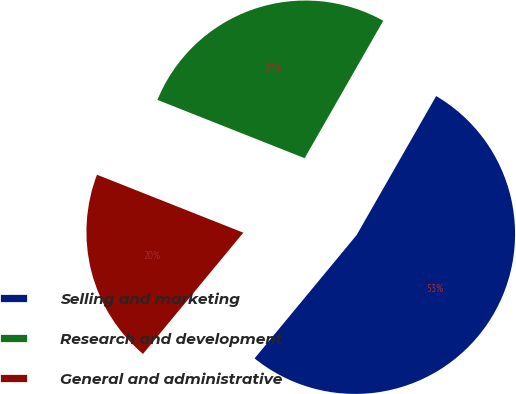Convert chart. <chart><loc_0><loc_0><loc_500><loc_500><pie_chart><fcel>Selling and marketing<fcel>Research and development<fcel>General and administrative<nl><fcel>52.73%<fcel>27.27%<fcel>20.0%<nl></chart> 